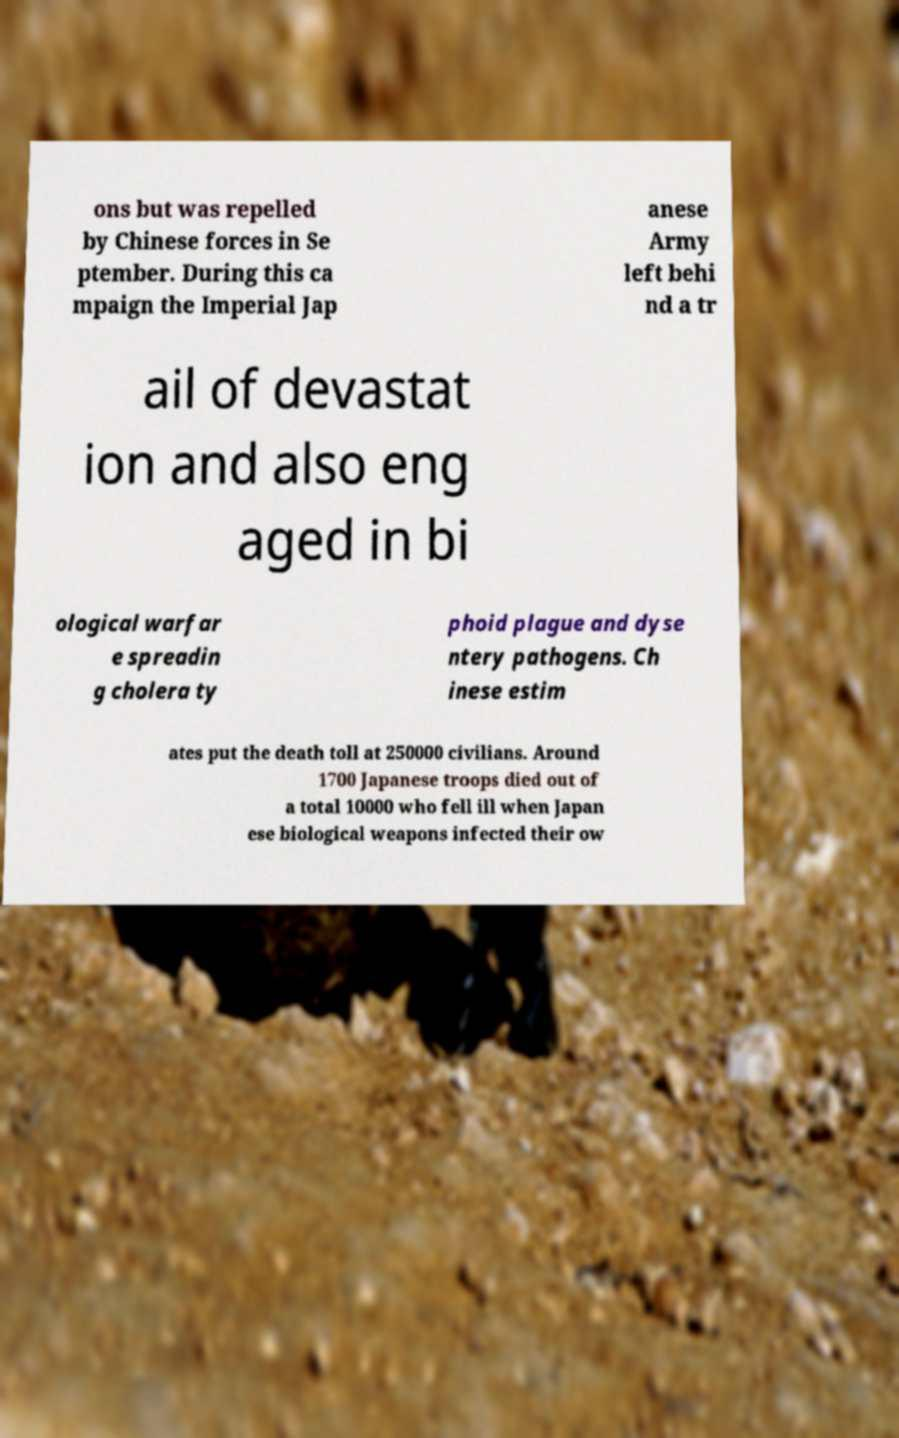For documentation purposes, I need the text within this image transcribed. Could you provide that? ons but was repelled by Chinese forces in Se ptember. During this ca mpaign the Imperial Jap anese Army left behi nd a tr ail of devastat ion and also eng aged in bi ological warfar e spreadin g cholera ty phoid plague and dyse ntery pathogens. Ch inese estim ates put the death toll at 250000 civilians. Around 1700 Japanese troops died out of a total 10000 who fell ill when Japan ese biological weapons infected their ow 